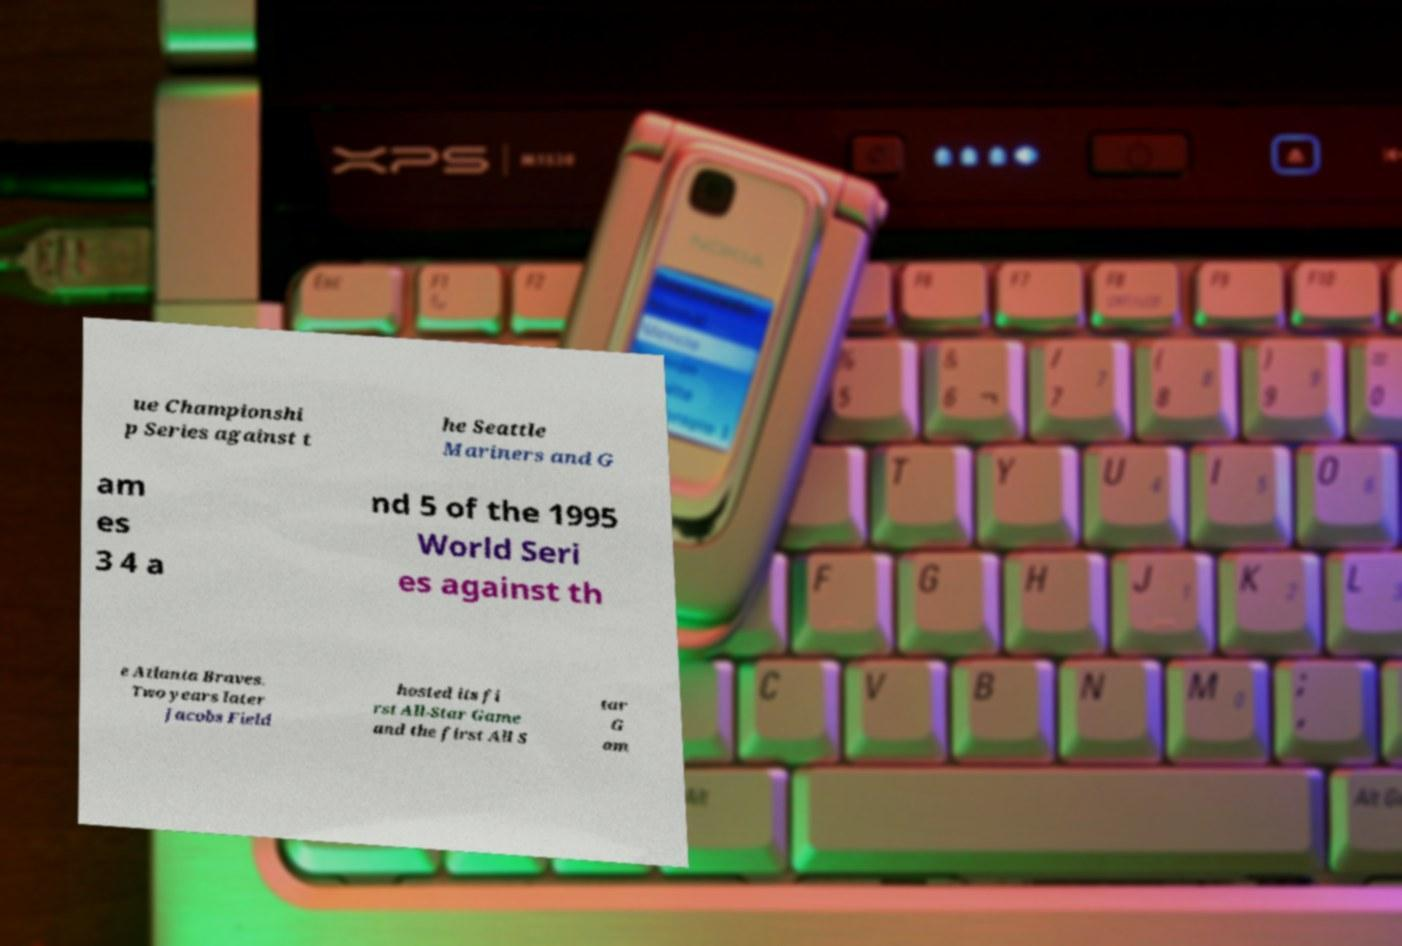Please identify and transcribe the text found in this image. ue Championshi p Series against t he Seattle Mariners and G am es 3 4 a nd 5 of the 1995 World Seri es against th e Atlanta Braves. Two years later Jacobs Field hosted its fi rst All-Star Game and the first All S tar G am 